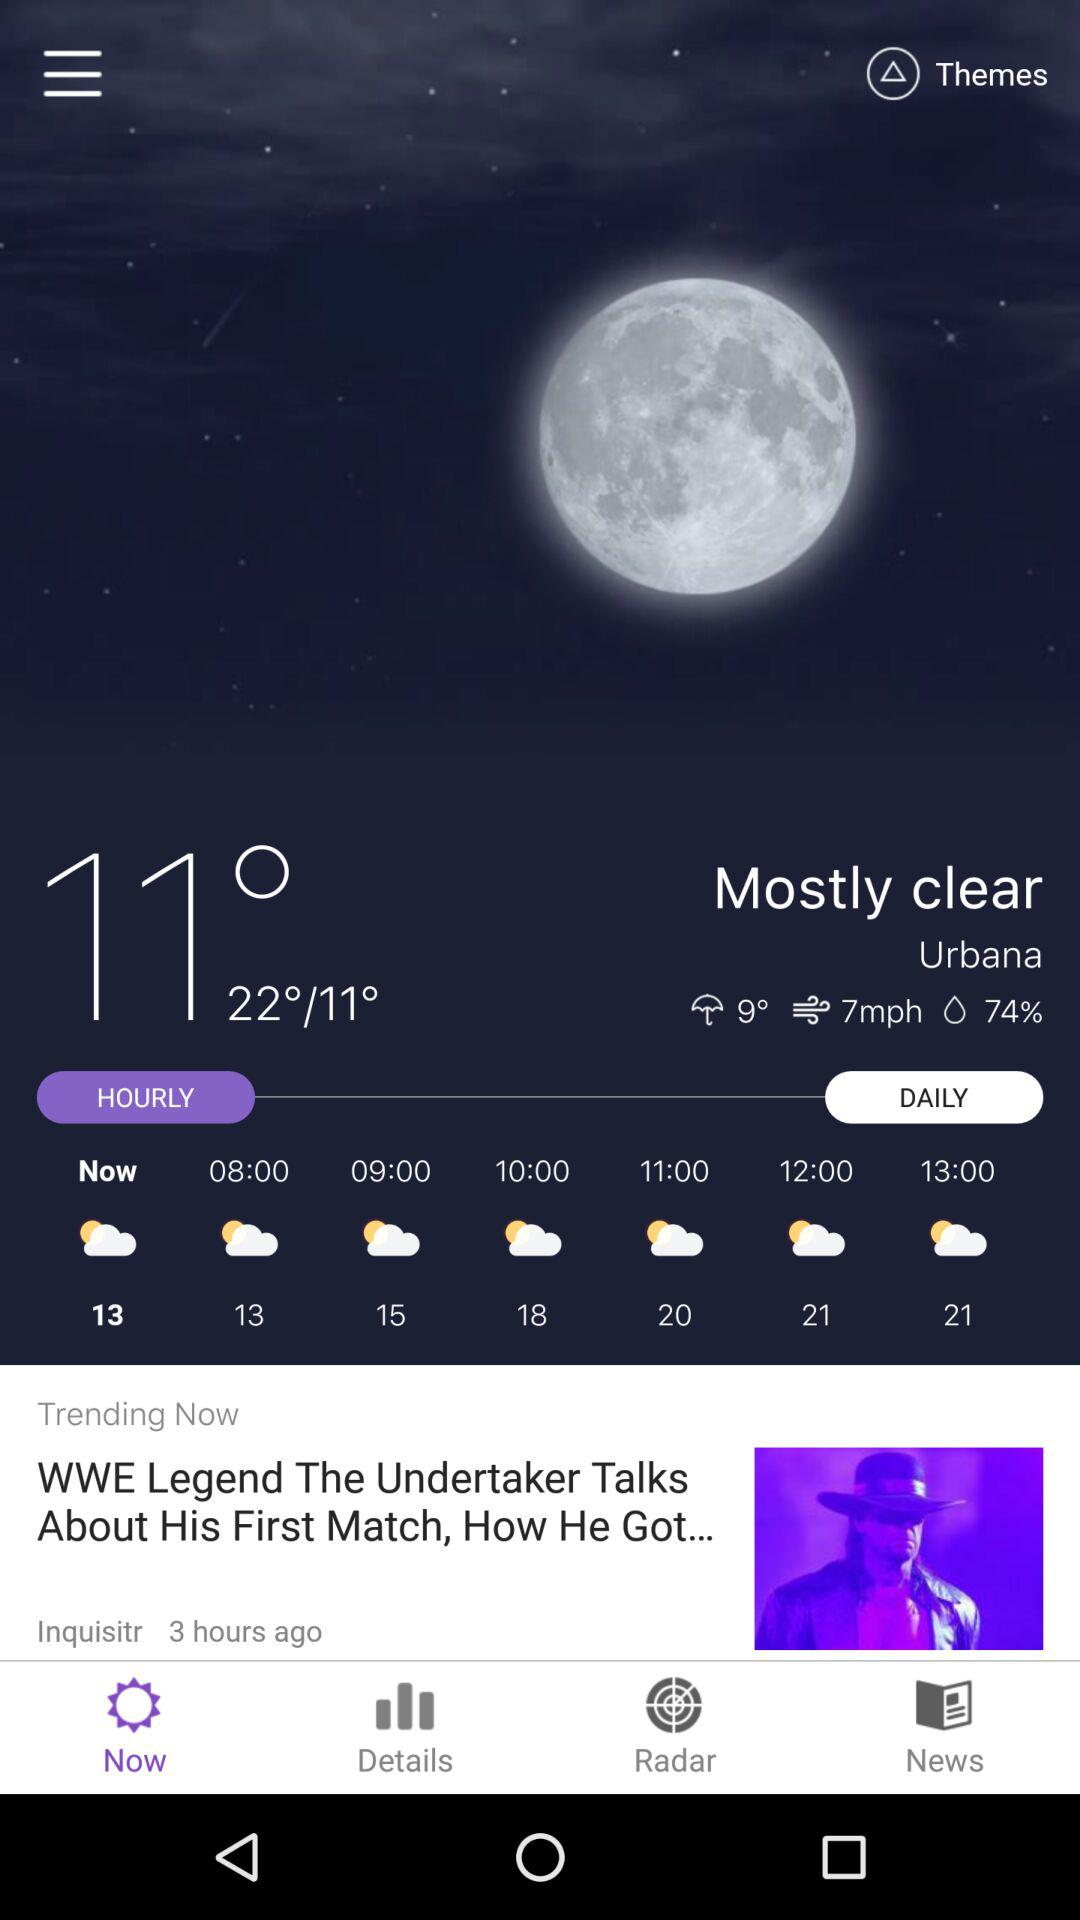How many degrees is the difference between the highest and lowest temperatures?
Answer the question using a single word or phrase. 11 